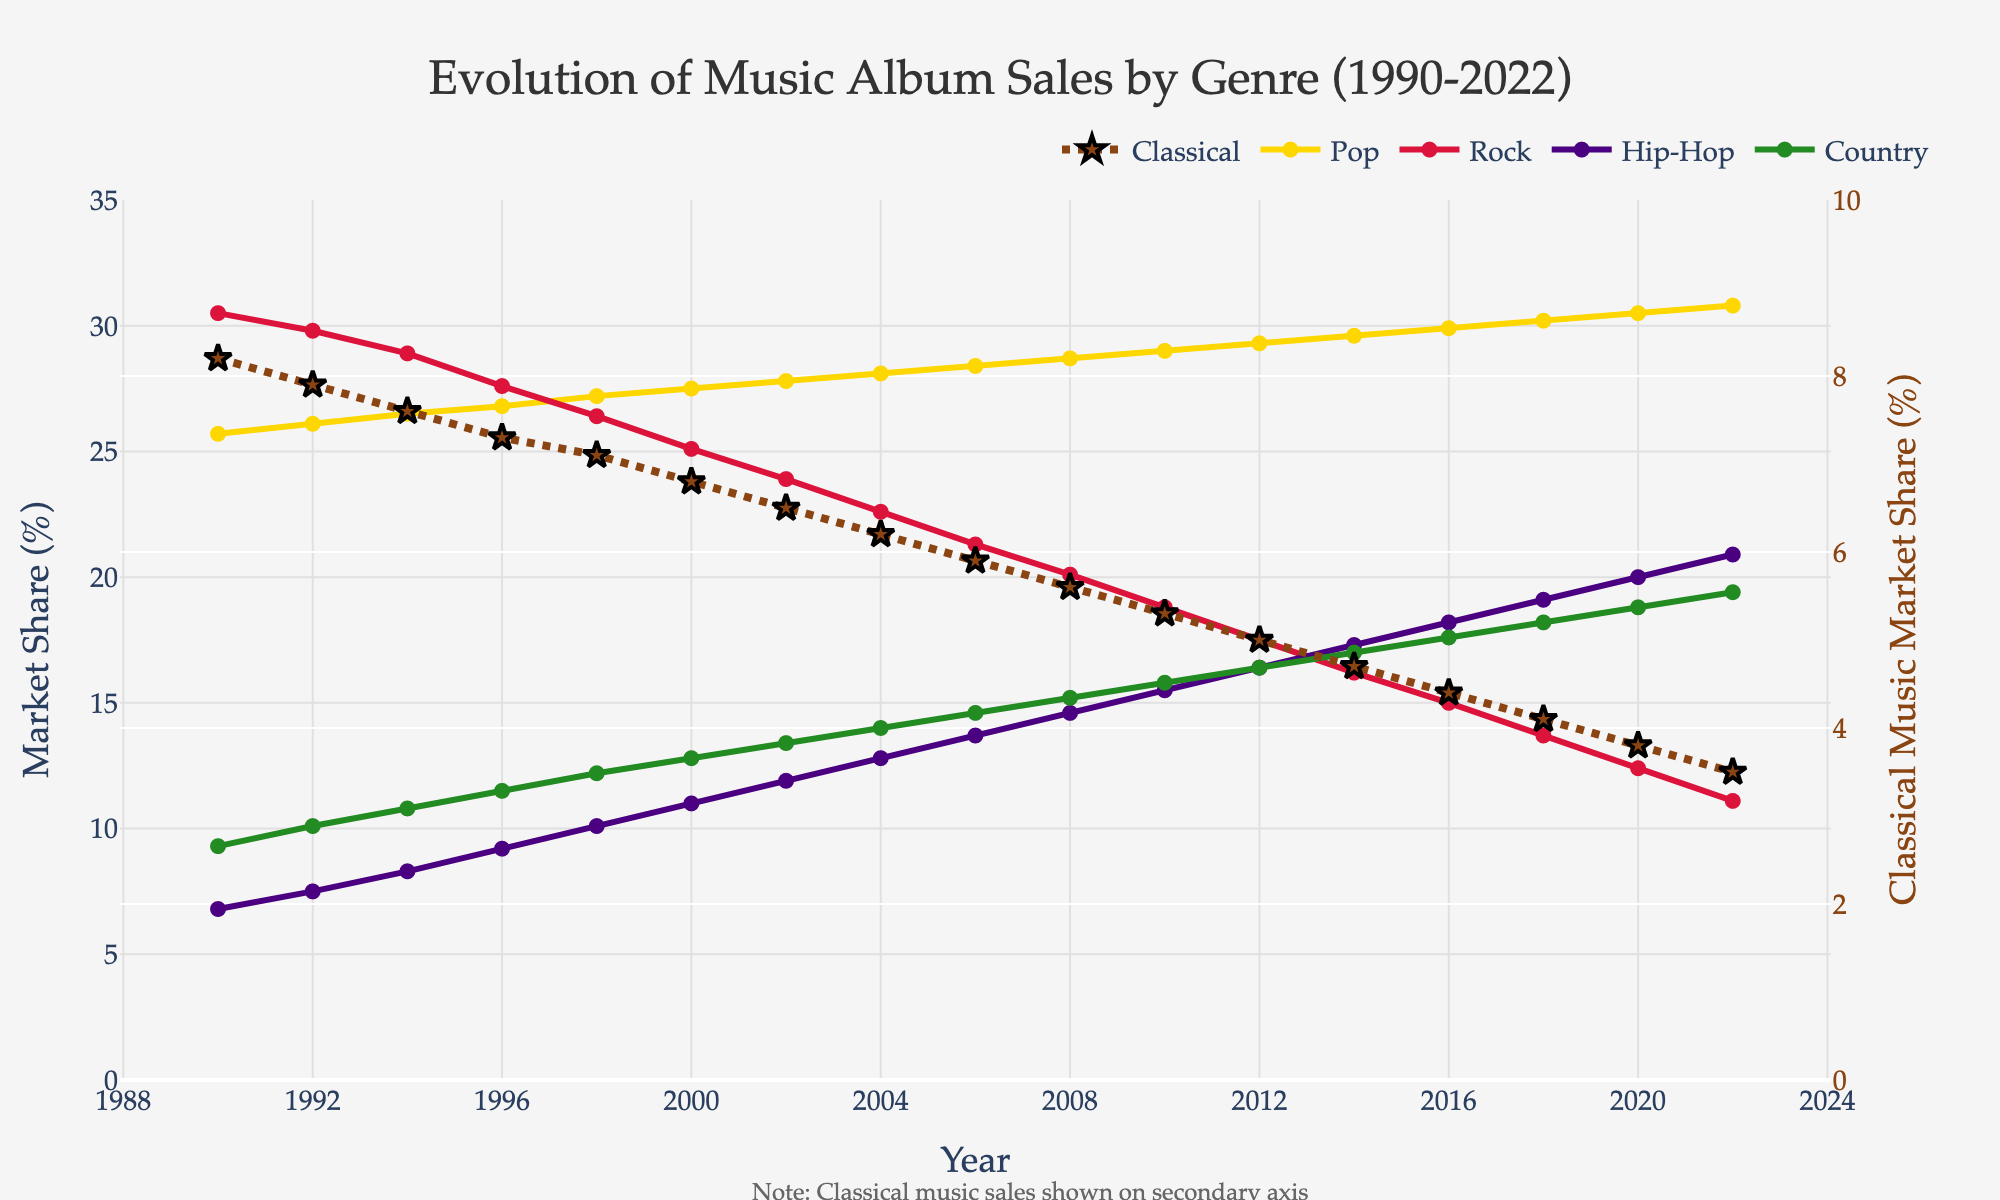What has been the trend of classical music album sales from 1990 to 2022? The classical music album sales have shown a decreasing trend. The market share has gradually declined from 8.2% in 1990 to 3.5% in 2022.
Answer: Decreasing Which genre had the highest market share in 2022? In 2022, the pop genre had the highest market share with an album sales share of 30.8%.
Answer: Pop By how much did the market share of rock music decline from 1990 to 2022? The rock music market share dropped from 30.5% in 1990 to 11.1% in 2022. The difference is 30.5 - 11.1 = 19.4 percentage points.
Answer: 19.4 How do the market shares of classical and hip-hop music in 2022 compare? In 2022, classical music had a market share of 3.5%, while hip-hop had a market share of 20.9%. Hip-hop has a significantly higher market share compared to classical music.
Answer: Hip-hop has a higher market share What is the overall trend in the market share of country music from 1990 to 2022? Country music has shown a steady increase in market share over the period. It started at 9.3% in 1990 and increased to 19.4% in 2022.
Answer: Increasing What was the market share of hip-hop compared to pop in 2000? In 2000, hip-hop had a market share of 11%, while pop had 27.5%. Pop had a much higher market share than hip-hop.
Answer: Pop had a higher market share By how much did the market share of pop music change from 1990 to 2022? Pop music's market share increased slightly from 25.7% in 1990 to 30.8% in 2022. The change is 30.8 - 25.7 = 5.1 percentage points.
Answer: 5.1 Which genre showed the most significant increase in market share from 1990 to 2022? Hip-hop showed the most significant increase in market share, rising from 6.8% in 1990 to 20.9% in 2022.
Answer: Hip-hop Identify the year when rock music saw its highest market share and specify the percentage. Rock music saw its highest market share in 1990 with 30.5%.
Answer: 1990, 30.5% 